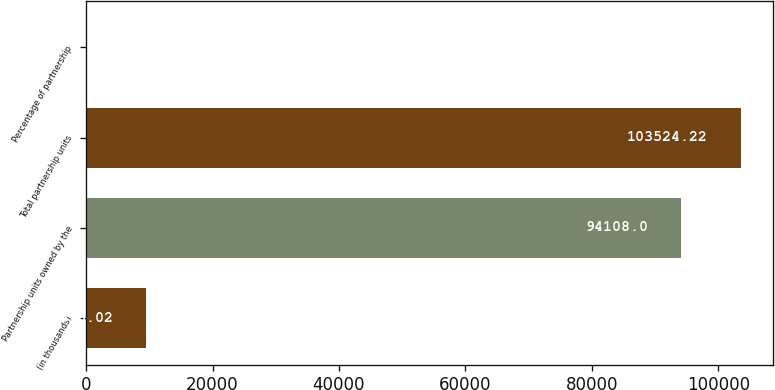Convert chart. <chart><loc_0><loc_0><loc_500><loc_500><bar_chart><fcel>(in thousands)<fcel>Partnership units owned by the<fcel>Total partnership units<fcel>Percentage of partnership<nl><fcel>9516.02<fcel>94108<fcel>103524<fcel>99.8<nl></chart> 